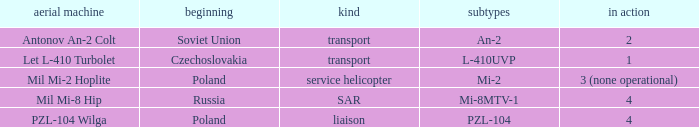Tell me the aircraft for pzl-104 PZL-104 Wilga. 